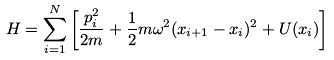<formula> <loc_0><loc_0><loc_500><loc_500>H = \sum ^ { N } _ { i = 1 } \left [ \frac { p ^ { 2 } _ { i } } { 2 m } + \frac { 1 } { 2 } m \omega ^ { 2 } ( x _ { i + 1 } - x _ { i } ) ^ { 2 } + U ( x _ { i } ) \right ]</formula> 